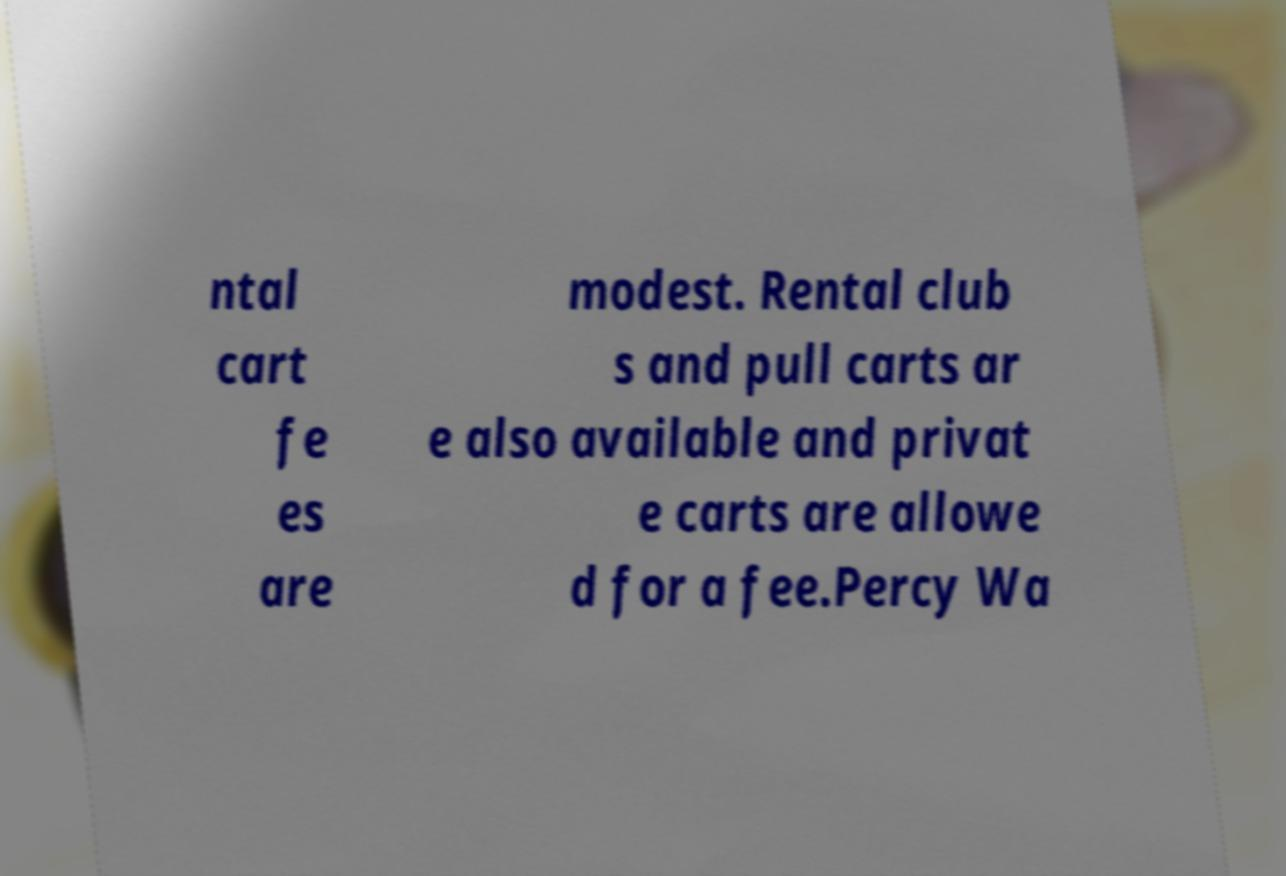Can you accurately transcribe the text from the provided image for me? ntal cart fe es are modest. Rental club s and pull carts ar e also available and privat e carts are allowe d for a fee.Percy Wa 